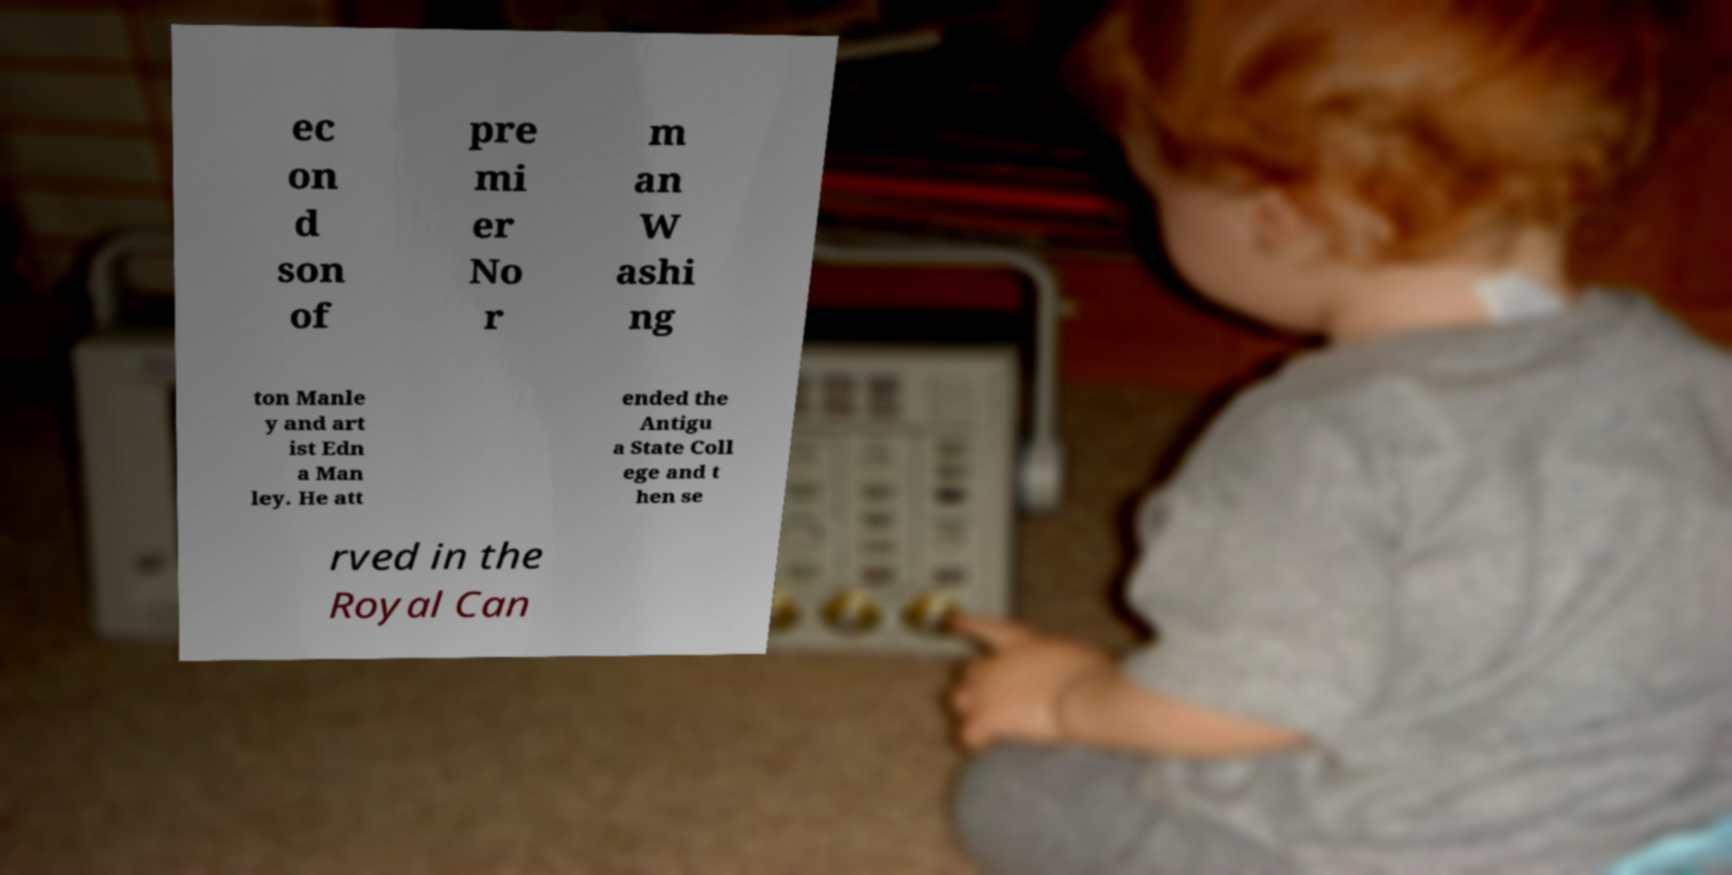There's text embedded in this image that I need extracted. Can you transcribe it verbatim? ec on d son of pre mi er No r m an W ashi ng ton Manle y and art ist Edn a Man ley. He att ended the Antigu a State Coll ege and t hen se rved in the Royal Can 